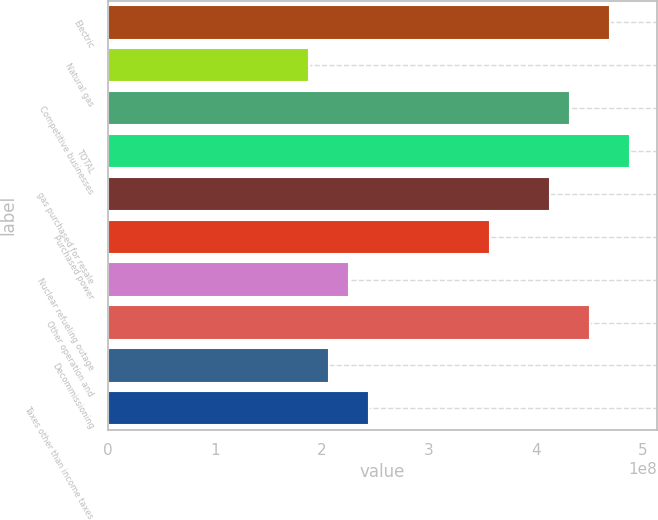<chart> <loc_0><loc_0><loc_500><loc_500><bar_chart><fcel>Electric<fcel>Natural gas<fcel>Competitive businesses<fcel>TOTAL<fcel>gas purchased for resale<fcel>Purchased power<fcel>Nuclear refueling outage<fcel>Other operation and<fcel>Decommissioning<fcel>Taxes other than income taxes<nl><fcel>4.69536e+08<fcel>1.87814e+08<fcel>4.31973e+08<fcel>4.88317e+08<fcel>4.13191e+08<fcel>3.56847e+08<fcel>2.25377e+08<fcel>4.50754e+08<fcel>2.06596e+08<fcel>2.44159e+08<nl></chart> 